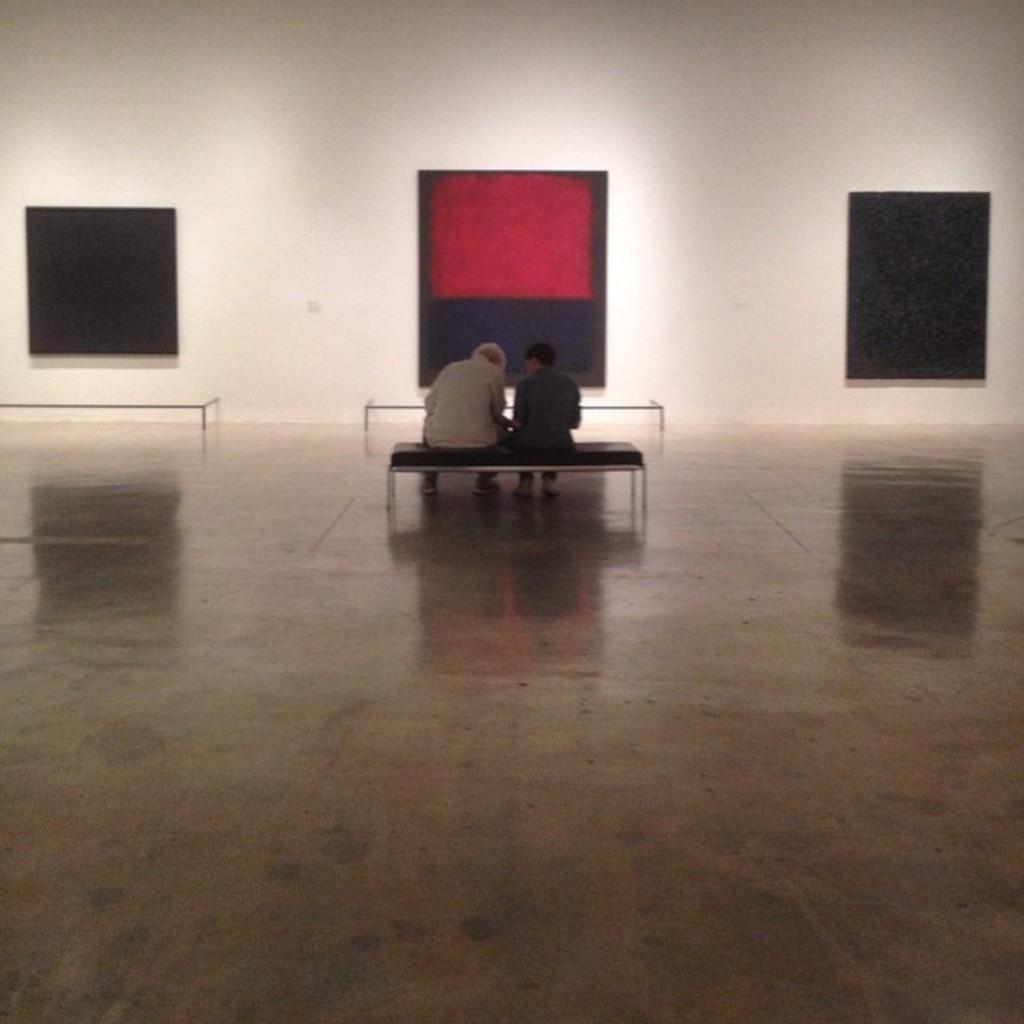Could you give a brief overview of what you see in this image? In this image we can see two persons sitting on the bench, there are two other benches, also we can see the wall, and windows. 